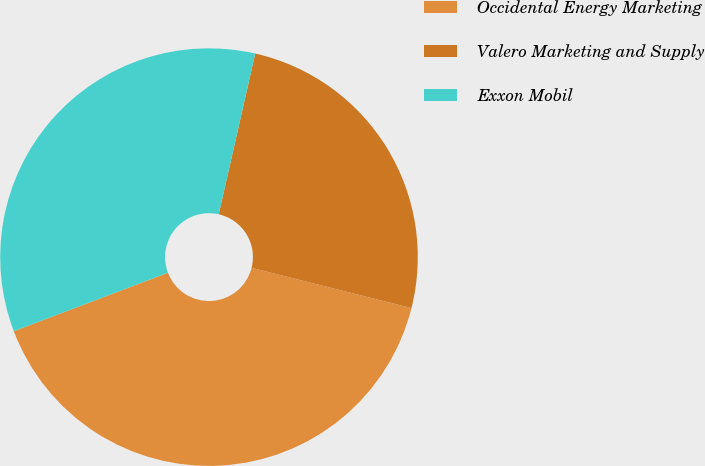Convert chart to OTSL. <chart><loc_0><loc_0><loc_500><loc_500><pie_chart><fcel>Occidental Energy Marketing<fcel>Valero Marketing and Supply<fcel>Exxon Mobil<nl><fcel>40.3%<fcel>25.37%<fcel>34.33%<nl></chart> 